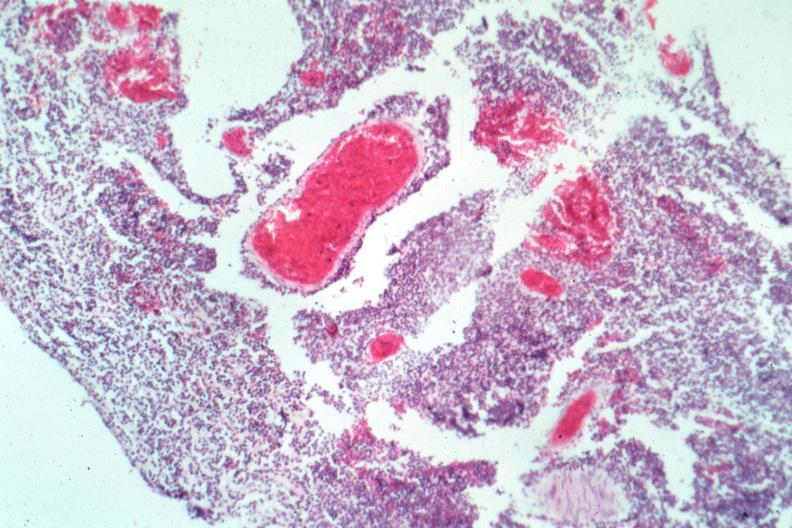what does this image show?
Answer the question using a single word or phrase. Typical not the best micrograph 